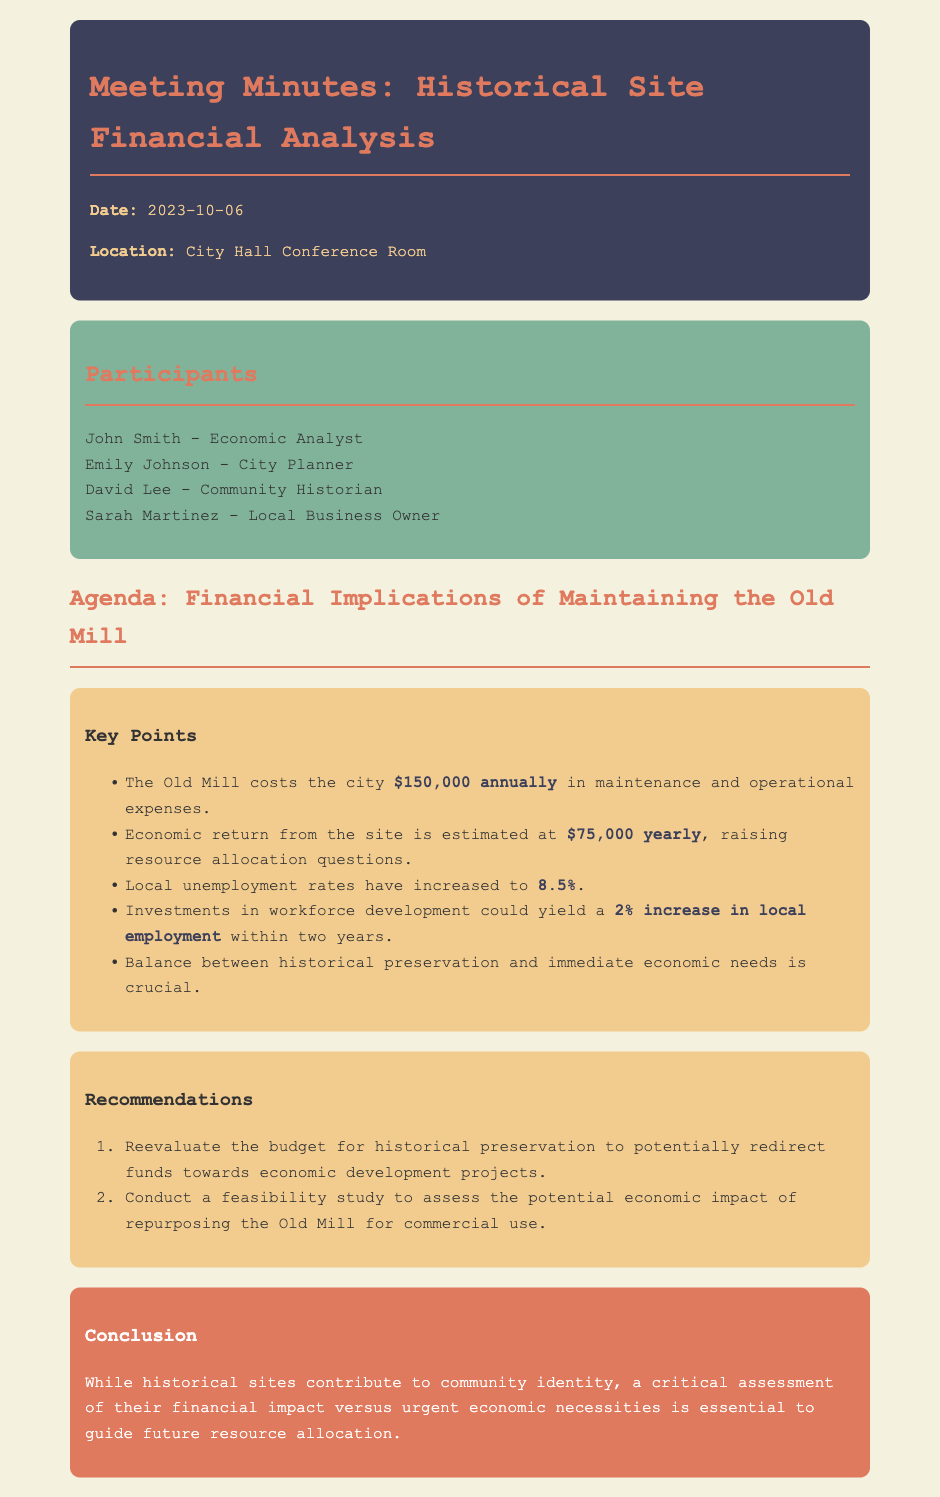What is the annual maintenance cost of the Old Mill? The document states that the Old Mill costs the city $150,000 annually in maintenance and operational expenses.
Answer: $150,000 What is the estimated economic return from the Old Mill? According to the document, the economic return from the site is estimated at $75,000 yearly.
Answer: $75,000 What is the current local unemployment rate? The document mentions that local unemployment rates have increased to 8.5%.
Answer: 8.5% What potential increase in local employment could result from investments in workforce development? The document states that investments in workforce development could yield a 2% increase in local employment within two years.
Answer: 2% What is a key balance mentioned in the document? The document emphasizes the balance between historical preservation and immediate economic needs.
Answer: historical preservation and immediate economic needs What is one recommendation made regarding the budget for historical preservation? The document recommends reevaluating the budget for historical preservation to potentially redirect funds towards economic development projects.
Answer: reevaluate the budget for historical preservation Who is the community historian participating in the meeting? The document lists David Lee as the community historian participating in the meeting.
Answer: David Lee What is the date of the meeting? The document notes that the meeting took place on October 6, 2023.
Answer: October 6, 2023 What is one aspect the conclusion highlights regarding historical sites? The conclusion emphasizes the need for a critical assessment of their financial impact versus urgent economic necessities.
Answer: financial impact versus urgent economic necessities 